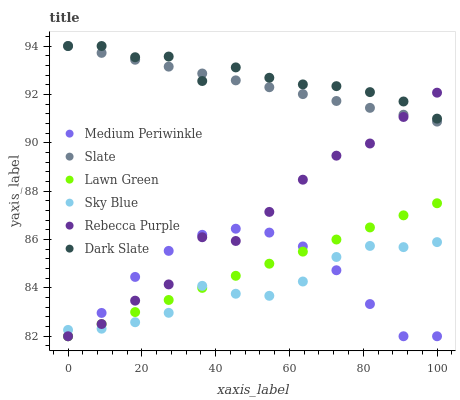Does Sky Blue have the minimum area under the curve?
Answer yes or no. Yes. Does Dark Slate have the maximum area under the curve?
Answer yes or no. Yes. Does Slate have the minimum area under the curve?
Answer yes or no. No. Does Slate have the maximum area under the curve?
Answer yes or no. No. Is Slate the smoothest?
Answer yes or no. Yes. Is Rebecca Purple the roughest?
Answer yes or no. Yes. Is Medium Periwinkle the smoothest?
Answer yes or no. No. Is Medium Periwinkle the roughest?
Answer yes or no. No. Does Lawn Green have the lowest value?
Answer yes or no. Yes. Does Slate have the lowest value?
Answer yes or no. No. Does Dark Slate have the highest value?
Answer yes or no. Yes. Does Medium Periwinkle have the highest value?
Answer yes or no. No. Is Medium Periwinkle less than Dark Slate?
Answer yes or no. Yes. Is Dark Slate greater than Medium Periwinkle?
Answer yes or no. Yes. Does Slate intersect Dark Slate?
Answer yes or no. Yes. Is Slate less than Dark Slate?
Answer yes or no. No. Is Slate greater than Dark Slate?
Answer yes or no. No. Does Medium Periwinkle intersect Dark Slate?
Answer yes or no. No. 